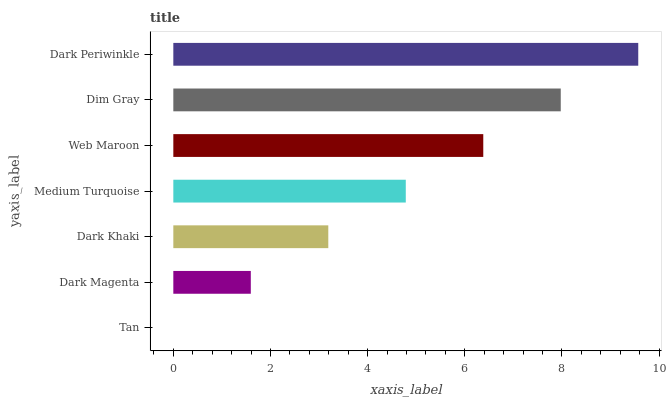Is Tan the minimum?
Answer yes or no. Yes. Is Dark Periwinkle the maximum?
Answer yes or no. Yes. Is Dark Magenta the minimum?
Answer yes or no. No. Is Dark Magenta the maximum?
Answer yes or no. No. Is Dark Magenta greater than Tan?
Answer yes or no. Yes. Is Tan less than Dark Magenta?
Answer yes or no. Yes. Is Tan greater than Dark Magenta?
Answer yes or no. No. Is Dark Magenta less than Tan?
Answer yes or no. No. Is Medium Turquoise the high median?
Answer yes or no. Yes. Is Medium Turquoise the low median?
Answer yes or no. Yes. Is Dark Khaki the high median?
Answer yes or no. No. Is Dim Gray the low median?
Answer yes or no. No. 